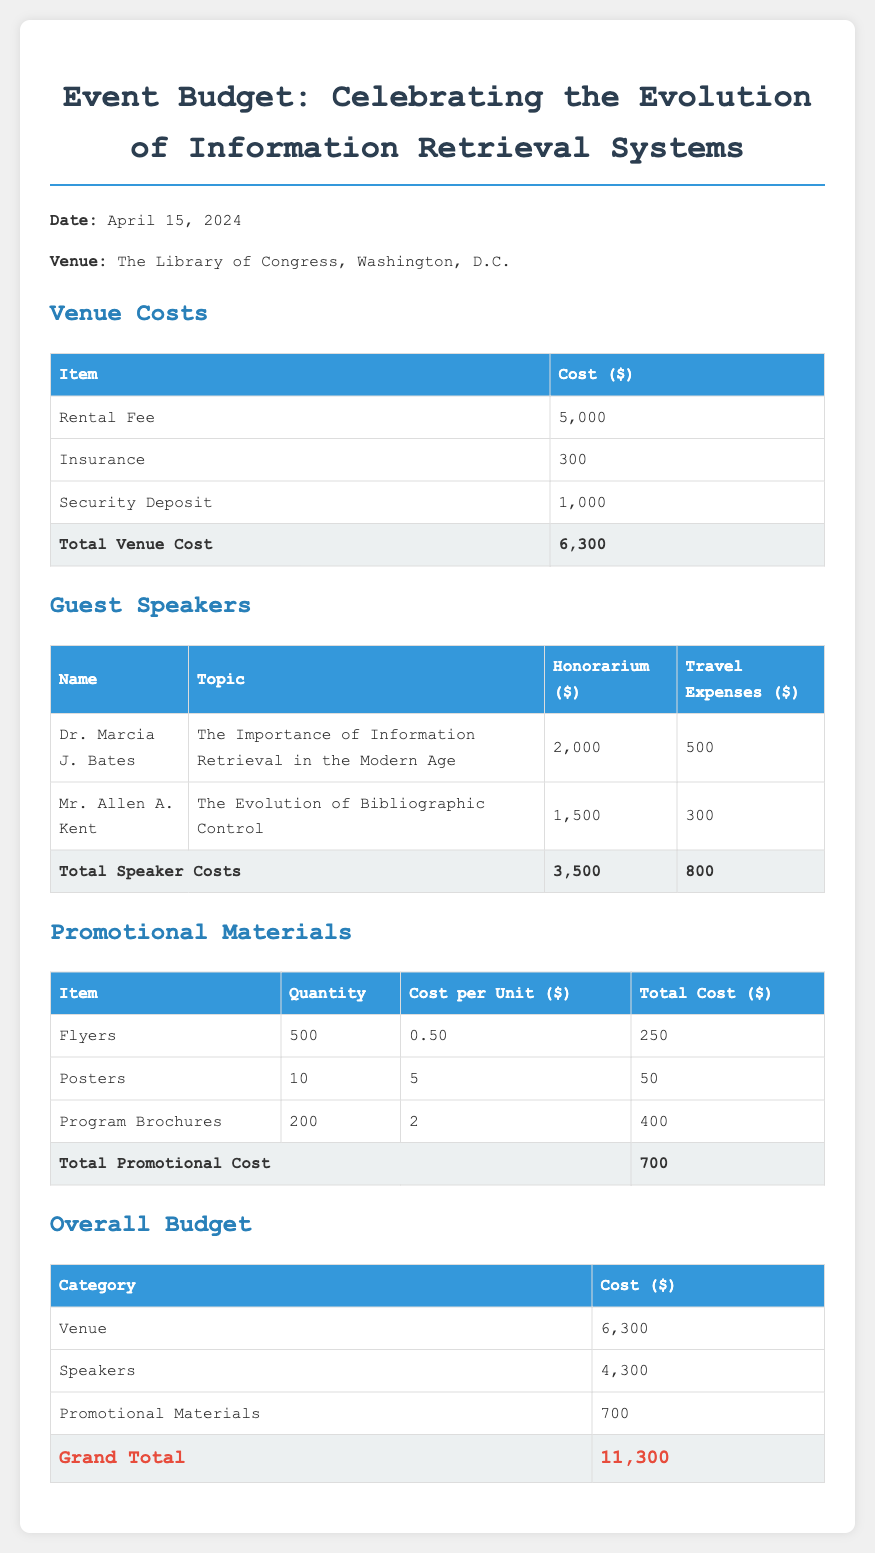What is the date of the event? The date of the event is mentioned at the beginning of the document.
Answer: April 15, 2024 What is the total venue cost? The total venue cost is calculated from the venue costs table in the document.
Answer: 6,300 Who is the first guest speaker? The first guest speaker's name is listed in the guest speakers table.
Answer: Dr. Marcia J. Bates What is the cost per unit of posters? The cost per unit of posters is specified in the promotional materials table.
Answer: 5 What is the grand total budget? The grand total budget is the sum of all categories in the overall budget section.
Answer: 11,300 How much is allocated for travel expenses for the guest speakers? The total travel expenses for guest speakers are shown in the guest speakers section.
Answer: 800 What venue is the event being held at? The venue name is stated clearly at the beginning of the document.
Answer: The Library of Congress, Washington, D.C Which promotional material has the largest total cost? The total cost for each promotional material is listed; we identify the highest among them.
Answer: Program Brochures What is the honorarium for Mr. Allen A. Kent? The specific honorarium amount for Mr. Allen A. Kent is provided in the guest speakers table.
Answer: 1,500 